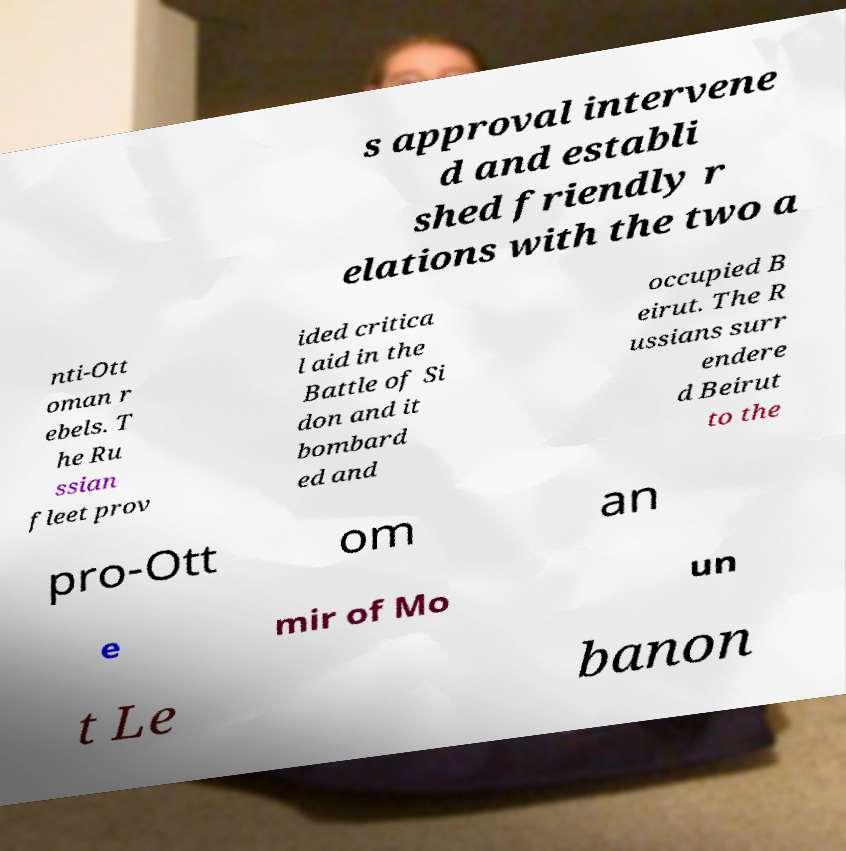For documentation purposes, I need the text within this image transcribed. Could you provide that? s approval intervene d and establi shed friendly r elations with the two a nti-Ott oman r ebels. T he Ru ssian fleet prov ided critica l aid in the Battle of Si don and it bombard ed and occupied B eirut. The R ussians surr endere d Beirut to the pro-Ott om an e mir of Mo un t Le banon 